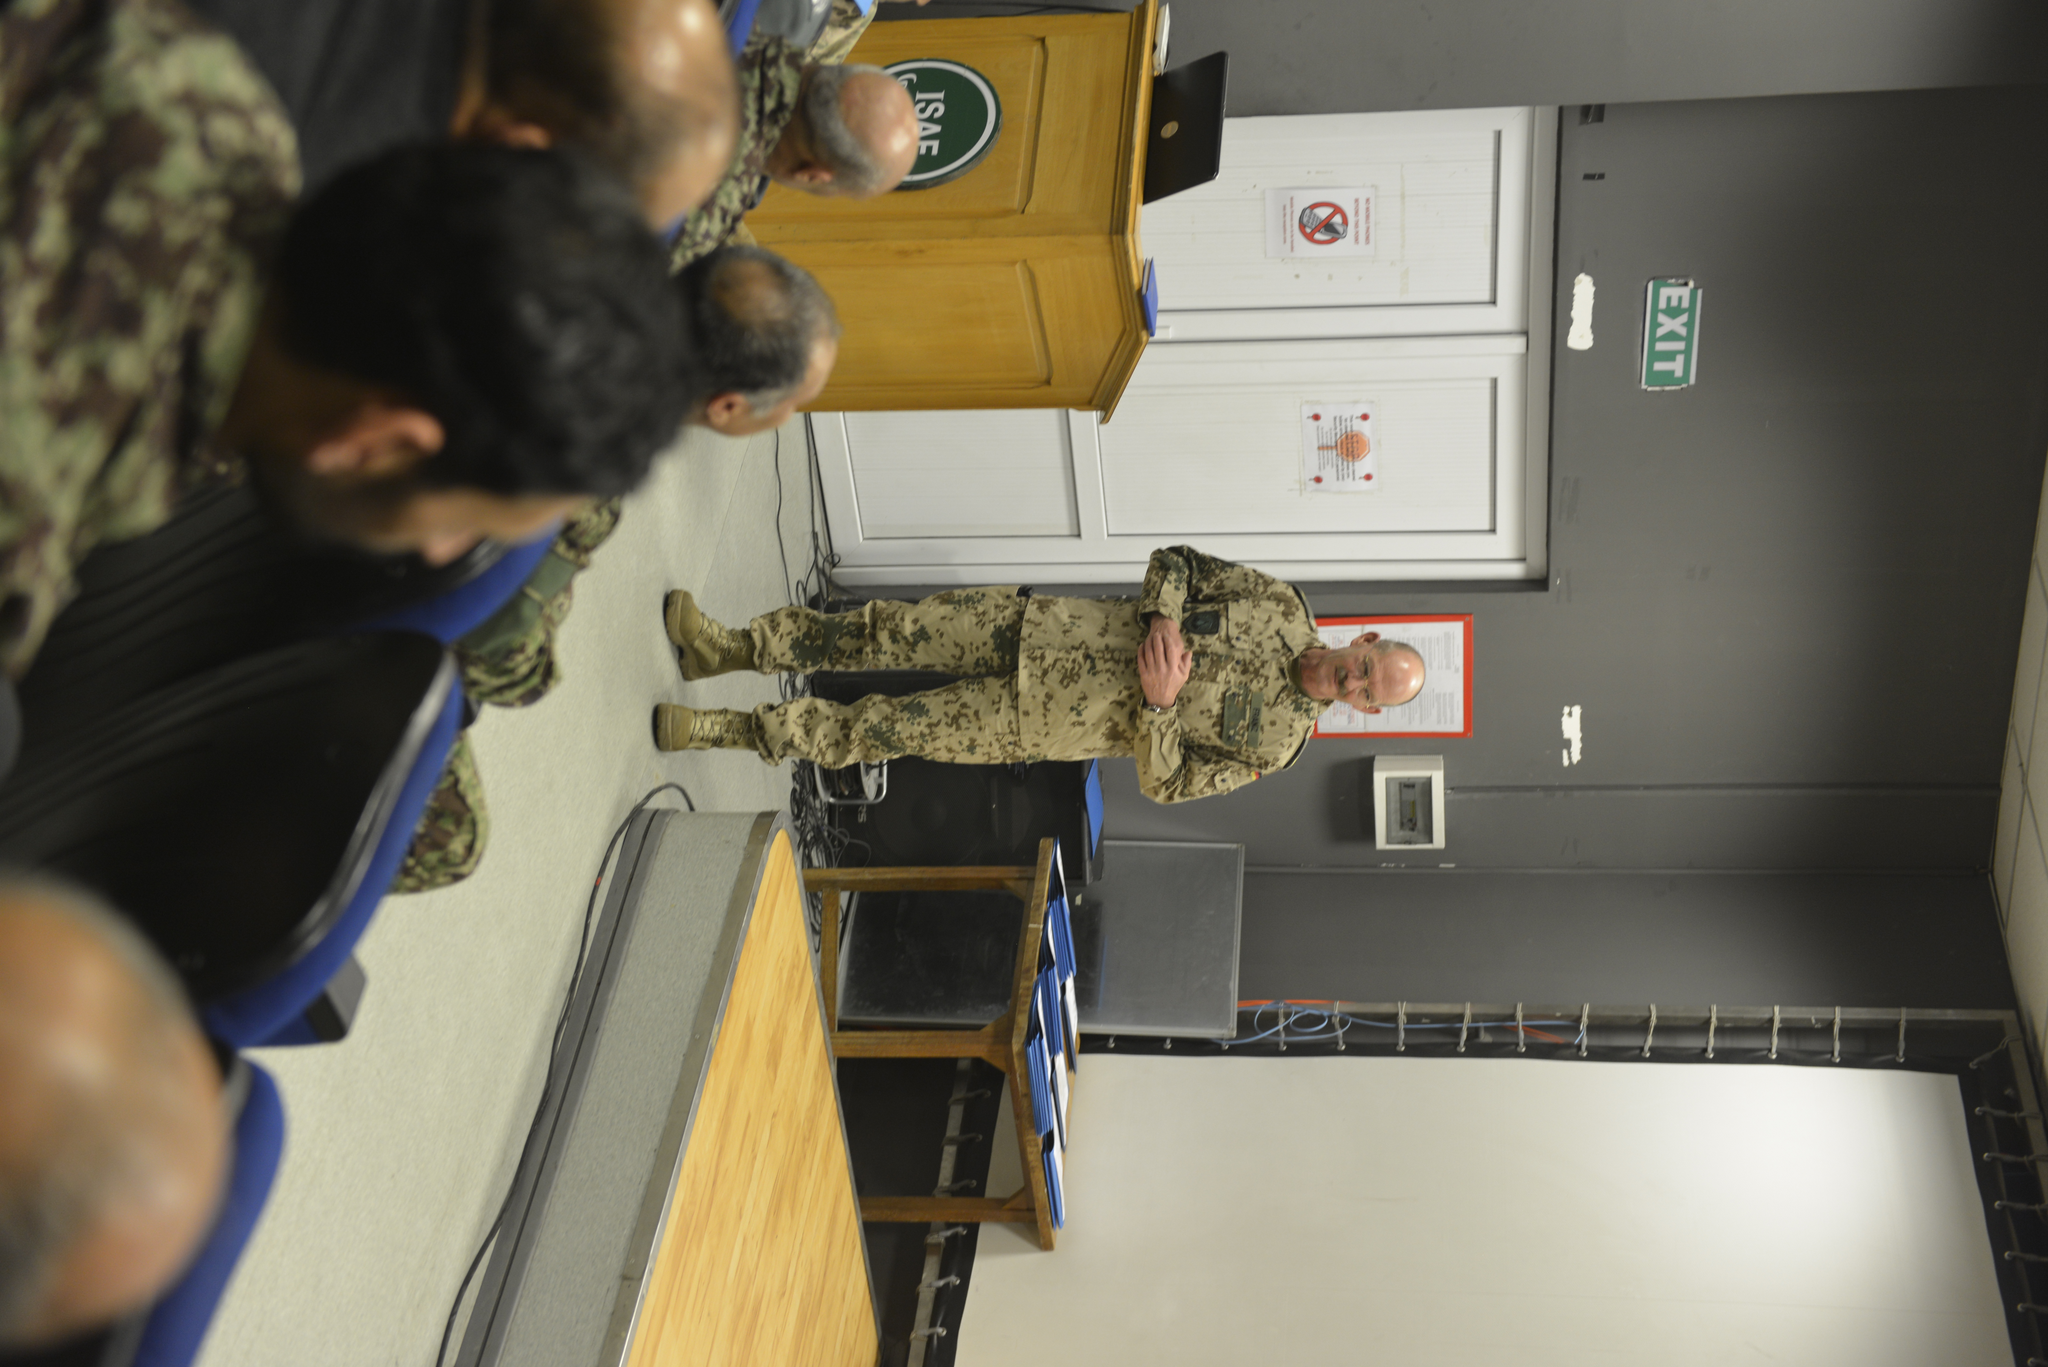Can you describe this image briefly? The image is taken in the room. In the center of the image there is a man standing, he is wearing a uniform. On the left there are people sitting on the chairs. In the center of the room there is a podium. In the background there is a door and wall. 